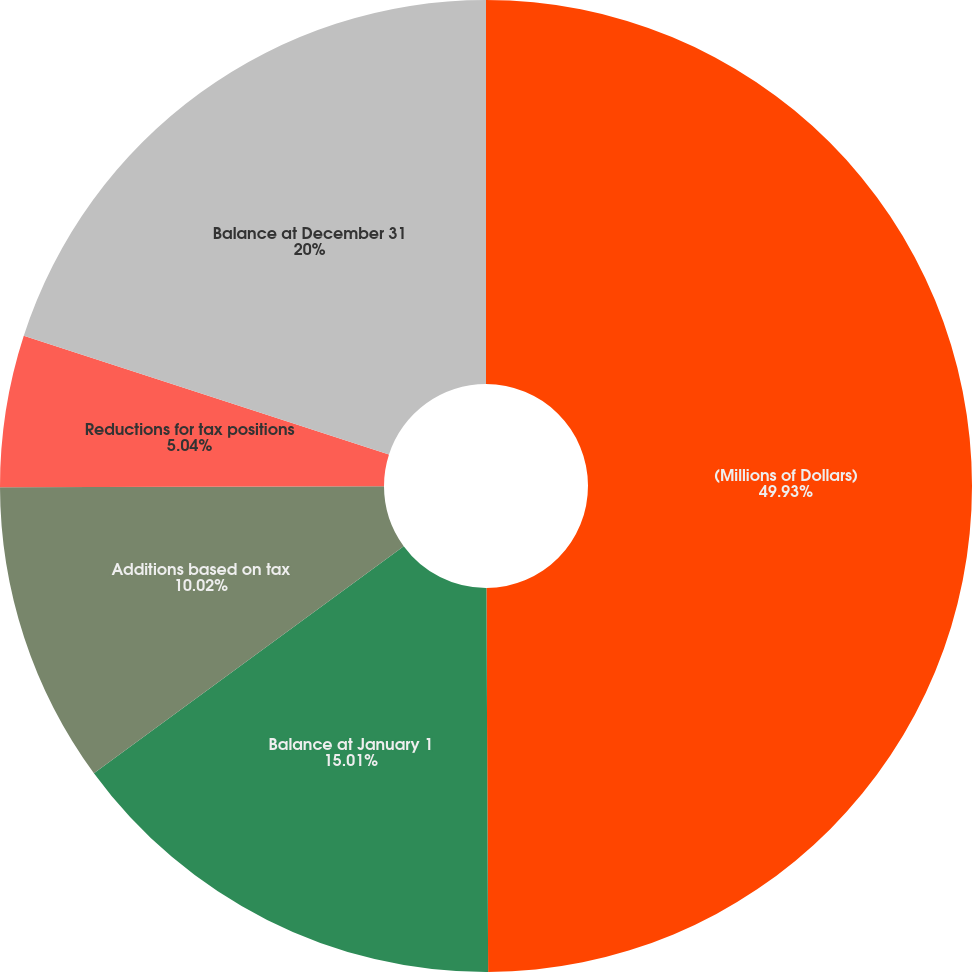<chart> <loc_0><loc_0><loc_500><loc_500><pie_chart><fcel>(Millions of Dollars)<fcel>Balance at January 1<fcel>Additions based on tax<fcel>Reductions for tax positions<fcel>Balance at December 31<nl><fcel>49.93%<fcel>15.01%<fcel>10.02%<fcel>5.04%<fcel>20.0%<nl></chart> 